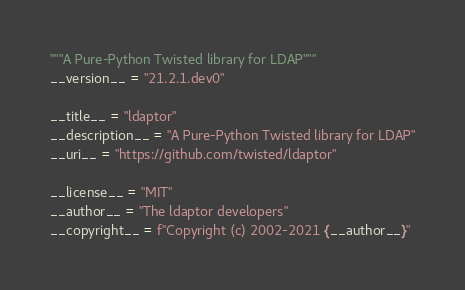<code> <loc_0><loc_0><loc_500><loc_500><_Python_>"""A Pure-Python Twisted library for LDAP"""
__version__ = "21.2.1.dev0"

__title__ = "ldaptor"
__description__ = "A Pure-Python Twisted library for LDAP"
__uri__ = "https://github.com/twisted/ldaptor"

__license__ = "MIT"
__author__ = "The ldaptor developers"
__copyright__ = f"Copyright (c) 2002-2021 {__author__}"
</code> 